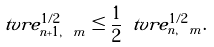Convert formula to latex. <formula><loc_0><loc_0><loc_500><loc_500>\ t v r e _ { n + 1 , \ m } ^ { 1 / 2 } \leq \frac { 1 } { 2 } \ t v r e _ { n , \ m } ^ { 1 / 2 } .</formula> 